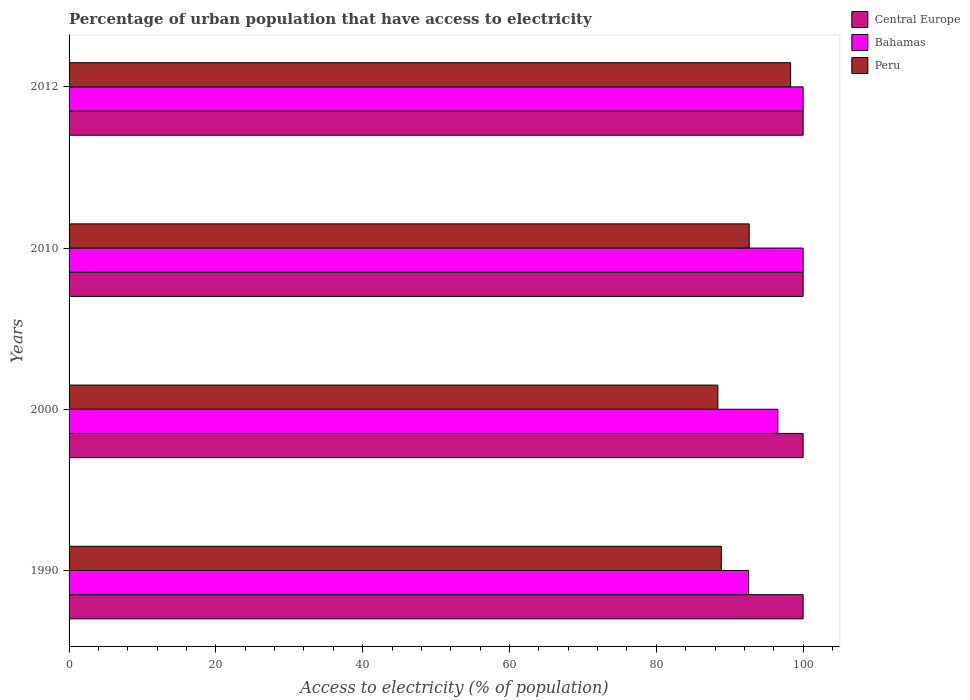How many groups of bars are there?
Offer a terse response. 4. How many bars are there on the 2nd tick from the top?
Offer a very short reply. 3. What is the label of the 1st group of bars from the top?
Make the answer very short. 2012. In how many cases, is the number of bars for a given year not equal to the number of legend labels?
Keep it short and to the point. 0. What is the percentage of urban population that have access to electricity in Peru in 1990?
Your response must be concise. 88.86. Across all years, what is the maximum percentage of urban population that have access to electricity in Peru?
Ensure brevity in your answer.  98.3. Across all years, what is the minimum percentage of urban population that have access to electricity in Peru?
Offer a terse response. 88.39. In which year was the percentage of urban population that have access to electricity in Central Europe minimum?
Make the answer very short. 1990. What is the total percentage of urban population that have access to electricity in Bahamas in the graph?
Ensure brevity in your answer.  389.13. What is the difference between the percentage of urban population that have access to electricity in Peru in 2000 and that in 2010?
Your response must be concise. -4.27. What is the difference between the percentage of urban population that have access to electricity in Peru in 2010 and the percentage of urban population that have access to electricity in Bahamas in 2000?
Give a very brief answer. -3.9. In the year 2000, what is the difference between the percentage of urban population that have access to electricity in Central Europe and percentage of urban population that have access to electricity in Bahamas?
Your answer should be very brief. 3.44. In how many years, is the percentage of urban population that have access to electricity in Bahamas greater than 96 %?
Your answer should be very brief. 3. Is the percentage of urban population that have access to electricity in Bahamas in 1990 less than that in 2010?
Provide a short and direct response. Yes. What is the difference between the highest and the second highest percentage of urban population that have access to electricity in Bahamas?
Provide a short and direct response. 0. What is the difference between the highest and the lowest percentage of urban population that have access to electricity in Peru?
Provide a succinct answer. 9.91. Is the sum of the percentage of urban population that have access to electricity in Bahamas in 1990 and 2000 greater than the maximum percentage of urban population that have access to electricity in Central Europe across all years?
Offer a very short reply. Yes. What does the 2nd bar from the top in 2010 represents?
Your answer should be compact. Bahamas. What does the 2nd bar from the bottom in 2000 represents?
Your answer should be very brief. Bahamas. Is it the case that in every year, the sum of the percentage of urban population that have access to electricity in Bahamas and percentage of urban population that have access to electricity in Central Europe is greater than the percentage of urban population that have access to electricity in Peru?
Offer a very short reply. Yes. How many years are there in the graph?
Offer a very short reply. 4. What is the difference between two consecutive major ticks on the X-axis?
Give a very brief answer. 20. Are the values on the major ticks of X-axis written in scientific E-notation?
Offer a very short reply. No. Where does the legend appear in the graph?
Your answer should be very brief. Top right. What is the title of the graph?
Your answer should be very brief. Percentage of urban population that have access to electricity. What is the label or title of the X-axis?
Offer a terse response. Access to electricity (% of population). What is the Access to electricity (% of population) in Bahamas in 1990?
Make the answer very short. 92.57. What is the Access to electricity (% of population) of Peru in 1990?
Ensure brevity in your answer.  88.86. What is the Access to electricity (% of population) of Central Europe in 2000?
Offer a terse response. 100. What is the Access to electricity (% of population) in Bahamas in 2000?
Give a very brief answer. 96.56. What is the Access to electricity (% of population) of Peru in 2000?
Ensure brevity in your answer.  88.39. What is the Access to electricity (% of population) of Peru in 2010?
Provide a short and direct response. 92.66. What is the Access to electricity (% of population) of Central Europe in 2012?
Keep it short and to the point. 100. What is the Access to electricity (% of population) in Bahamas in 2012?
Keep it short and to the point. 100. What is the Access to electricity (% of population) of Peru in 2012?
Your response must be concise. 98.3. Across all years, what is the maximum Access to electricity (% of population) of Peru?
Give a very brief answer. 98.3. Across all years, what is the minimum Access to electricity (% of population) of Bahamas?
Give a very brief answer. 92.57. Across all years, what is the minimum Access to electricity (% of population) of Peru?
Your answer should be compact. 88.39. What is the total Access to electricity (% of population) of Central Europe in the graph?
Offer a very short reply. 400. What is the total Access to electricity (% of population) in Bahamas in the graph?
Offer a very short reply. 389.13. What is the total Access to electricity (% of population) in Peru in the graph?
Ensure brevity in your answer.  368.2. What is the difference between the Access to electricity (% of population) in Central Europe in 1990 and that in 2000?
Ensure brevity in your answer.  0. What is the difference between the Access to electricity (% of population) of Bahamas in 1990 and that in 2000?
Make the answer very short. -3.99. What is the difference between the Access to electricity (% of population) of Peru in 1990 and that in 2000?
Offer a very short reply. 0.47. What is the difference between the Access to electricity (% of population) in Bahamas in 1990 and that in 2010?
Your answer should be compact. -7.43. What is the difference between the Access to electricity (% of population) in Peru in 1990 and that in 2010?
Your response must be concise. -3.8. What is the difference between the Access to electricity (% of population) of Central Europe in 1990 and that in 2012?
Give a very brief answer. 0. What is the difference between the Access to electricity (% of population) in Bahamas in 1990 and that in 2012?
Offer a terse response. -7.43. What is the difference between the Access to electricity (% of population) of Peru in 1990 and that in 2012?
Give a very brief answer. -9.44. What is the difference between the Access to electricity (% of population) of Central Europe in 2000 and that in 2010?
Your answer should be very brief. 0. What is the difference between the Access to electricity (% of population) in Bahamas in 2000 and that in 2010?
Make the answer very short. -3.44. What is the difference between the Access to electricity (% of population) of Peru in 2000 and that in 2010?
Provide a short and direct response. -4.27. What is the difference between the Access to electricity (% of population) in Central Europe in 2000 and that in 2012?
Your response must be concise. 0. What is the difference between the Access to electricity (% of population) in Bahamas in 2000 and that in 2012?
Provide a succinct answer. -3.44. What is the difference between the Access to electricity (% of population) of Peru in 2000 and that in 2012?
Your answer should be compact. -9.91. What is the difference between the Access to electricity (% of population) in Central Europe in 2010 and that in 2012?
Offer a very short reply. 0. What is the difference between the Access to electricity (% of population) of Peru in 2010 and that in 2012?
Your response must be concise. -5.64. What is the difference between the Access to electricity (% of population) in Central Europe in 1990 and the Access to electricity (% of population) in Bahamas in 2000?
Offer a very short reply. 3.44. What is the difference between the Access to electricity (% of population) of Central Europe in 1990 and the Access to electricity (% of population) of Peru in 2000?
Make the answer very short. 11.61. What is the difference between the Access to electricity (% of population) in Bahamas in 1990 and the Access to electricity (% of population) in Peru in 2000?
Give a very brief answer. 4.19. What is the difference between the Access to electricity (% of population) of Central Europe in 1990 and the Access to electricity (% of population) of Bahamas in 2010?
Give a very brief answer. 0. What is the difference between the Access to electricity (% of population) in Central Europe in 1990 and the Access to electricity (% of population) in Peru in 2010?
Your answer should be compact. 7.34. What is the difference between the Access to electricity (% of population) in Bahamas in 1990 and the Access to electricity (% of population) in Peru in 2010?
Provide a succinct answer. -0.08. What is the difference between the Access to electricity (% of population) in Central Europe in 1990 and the Access to electricity (% of population) in Bahamas in 2012?
Offer a very short reply. 0. What is the difference between the Access to electricity (% of population) of Bahamas in 1990 and the Access to electricity (% of population) of Peru in 2012?
Your answer should be very brief. -5.73. What is the difference between the Access to electricity (% of population) of Central Europe in 2000 and the Access to electricity (% of population) of Peru in 2010?
Ensure brevity in your answer.  7.34. What is the difference between the Access to electricity (% of population) in Bahamas in 2000 and the Access to electricity (% of population) in Peru in 2010?
Your answer should be compact. 3.9. What is the difference between the Access to electricity (% of population) in Central Europe in 2000 and the Access to electricity (% of population) in Peru in 2012?
Make the answer very short. 1.7. What is the difference between the Access to electricity (% of population) of Bahamas in 2000 and the Access to electricity (% of population) of Peru in 2012?
Offer a terse response. -1.74. What is the difference between the Access to electricity (% of population) in Central Europe in 2010 and the Access to electricity (% of population) in Peru in 2012?
Your response must be concise. 1.7. What is the average Access to electricity (% of population) of Central Europe per year?
Your response must be concise. 100. What is the average Access to electricity (% of population) of Bahamas per year?
Your answer should be very brief. 97.28. What is the average Access to electricity (% of population) in Peru per year?
Your answer should be very brief. 92.05. In the year 1990, what is the difference between the Access to electricity (% of population) in Central Europe and Access to electricity (% of population) in Bahamas?
Provide a short and direct response. 7.43. In the year 1990, what is the difference between the Access to electricity (% of population) of Central Europe and Access to electricity (% of population) of Peru?
Offer a very short reply. 11.14. In the year 1990, what is the difference between the Access to electricity (% of population) of Bahamas and Access to electricity (% of population) of Peru?
Provide a short and direct response. 3.71. In the year 2000, what is the difference between the Access to electricity (% of population) of Central Europe and Access to electricity (% of population) of Bahamas?
Provide a short and direct response. 3.44. In the year 2000, what is the difference between the Access to electricity (% of population) of Central Europe and Access to electricity (% of population) of Peru?
Your response must be concise. 11.61. In the year 2000, what is the difference between the Access to electricity (% of population) in Bahamas and Access to electricity (% of population) in Peru?
Give a very brief answer. 8.17. In the year 2010, what is the difference between the Access to electricity (% of population) in Central Europe and Access to electricity (% of population) in Bahamas?
Your answer should be compact. 0. In the year 2010, what is the difference between the Access to electricity (% of population) of Central Europe and Access to electricity (% of population) of Peru?
Your answer should be very brief. 7.34. In the year 2010, what is the difference between the Access to electricity (% of population) in Bahamas and Access to electricity (% of population) in Peru?
Offer a terse response. 7.34. In the year 2012, what is the difference between the Access to electricity (% of population) in Central Europe and Access to electricity (% of population) in Bahamas?
Provide a succinct answer. 0. What is the ratio of the Access to electricity (% of population) in Central Europe in 1990 to that in 2000?
Make the answer very short. 1. What is the ratio of the Access to electricity (% of population) in Bahamas in 1990 to that in 2000?
Provide a short and direct response. 0.96. What is the ratio of the Access to electricity (% of population) of Peru in 1990 to that in 2000?
Provide a short and direct response. 1.01. What is the ratio of the Access to electricity (% of population) in Central Europe in 1990 to that in 2010?
Make the answer very short. 1. What is the ratio of the Access to electricity (% of population) in Bahamas in 1990 to that in 2010?
Ensure brevity in your answer.  0.93. What is the ratio of the Access to electricity (% of population) of Peru in 1990 to that in 2010?
Provide a succinct answer. 0.96. What is the ratio of the Access to electricity (% of population) in Bahamas in 1990 to that in 2012?
Your answer should be very brief. 0.93. What is the ratio of the Access to electricity (% of population) in Peru in 1990 to that in 2012?
Provide a succinct answer. 0.9. What is the ratio of the Access to electricity (% of population) in Central Europe in 2000 to that in 2010?
Make the answer very short. 1. What is the ratio of the Access to electricity (% of population) in Bahamas in 2000 to that in 2010?
Offer a terse response. 0.97. What is the ratio of the Access to electricity (% of population) of Peru in 2000 to that in 2010?
Provide a succinct answer. 0.95. What is the ratio of the Access to electricity (% of population) in Bahamas in 2000 to that in 2012?
Ensure brevity in your answer.  0.97. What is the ratio of the Access to electricity (% of population) of Peru in 2000 to that in 2012?
Make the answer very short. 0.9. What is the ratio of the Access to electricity (% of population) of Peru in 2010 to that in 2012?
Provide a succinct answer. 0.94. What is the difference between the highest and the second highest Access to electricity (% of population) of Central Europe?
Offer a very short reply. 0. What is the difference between the highest and the second highest Access to electricity (% of population) in Peru?
Make the answer very short. 5.64. What is the difference between the highest and the lowest Access to electricity (% of population) of Central Europe?
Ensure brevity in your answer.  0. What is the difference between the highest and the lowest Access to electricity (% of population) of Bahamas?
Ensure brevity in your answer.  7.43. What is the difference between the highest and the lowest Access to electricity (% of population) in Peru?
Your response must be concise. 9.91. 